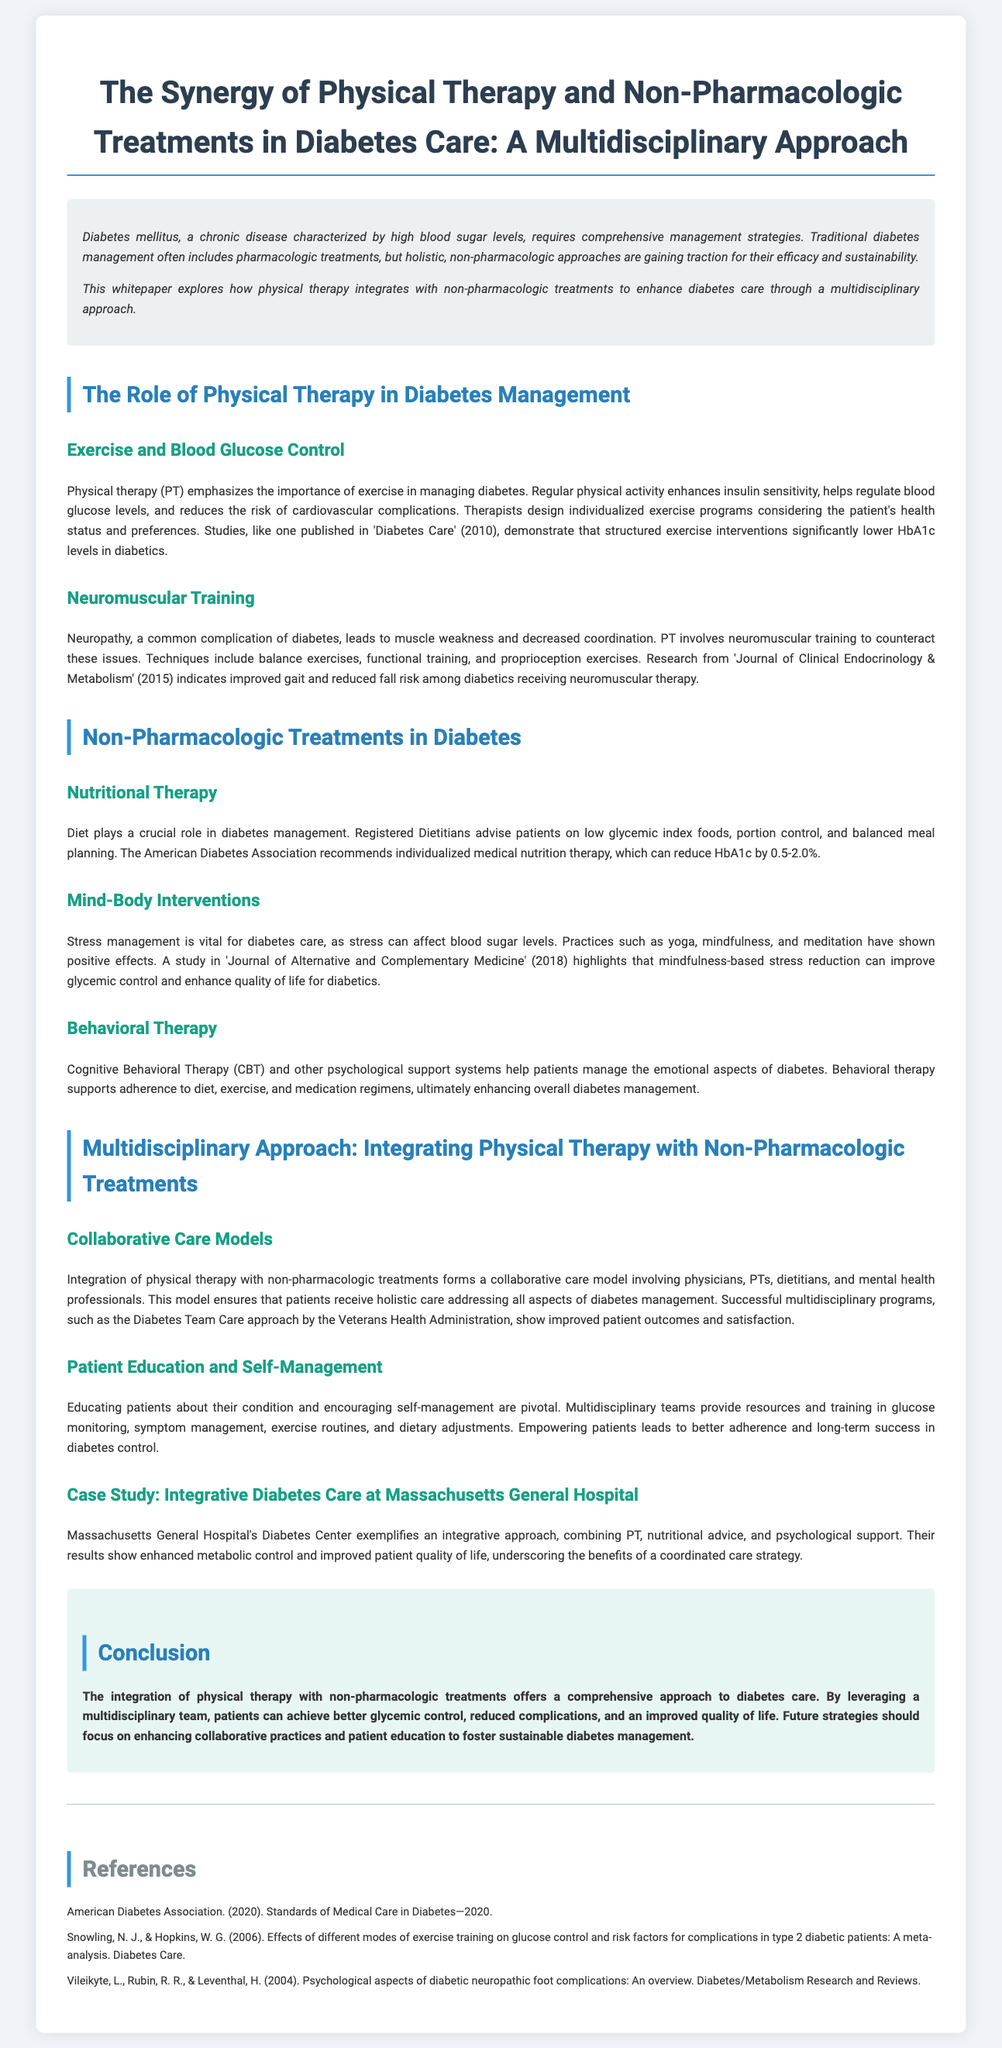What is the focus of the whitepaper? The whitepaper focuses on the integration of physical therapy with non-pharmacologic treatments in diabetes care.
Answer: Integration of physical therapy with non-pharmacologic treatments in diabetes care What is the effect of regular physical activity on blood glucose levels? Regular physical activity enhances insulin sensitivity and helps regulate blood glucose levels.
Answer: Enhances insulin sensitivity and helps regulate blood glucose levels What is one method mentioned for addressing diabetic neuropathy? Neuromuscular training, which includes balance exercises and functional training, is mentioned as a method.
Answer: Neuromuscular training What decrease in HbA1c can nutritional therapy achieve? Individualized medical nutrition therapy can reduce HbA1c by 0.5-2.0%.
Answer: 0.5-2.0% Which study highlights the benefits of mindfulness-based stress reduction? A study in the Journal of Alternative and Complementary Medicine (2018) shows the benefits.
Answer: Journal of Alternative and Complementary Medicine (2018) What model is used for collaborative care in diabetes management? The Diabetes Team Care approach by the Veterans Health Administration is an example of a collaborative care model.
Answer: Diabetes Team Care approach What type of therapy helps manage emotional aspects of diabetes? Cognitive Behavioral Therapy (CBT) is mentioned for managing emotional aspects.
Answer: Cognitive Behavioral Therapy (CBT) What does Massachusetts General Hospital's Diabetes Center exemplify? It exemplifies an integrative approach to diabetes care.
Answer: An integrative approach to diabetes care 